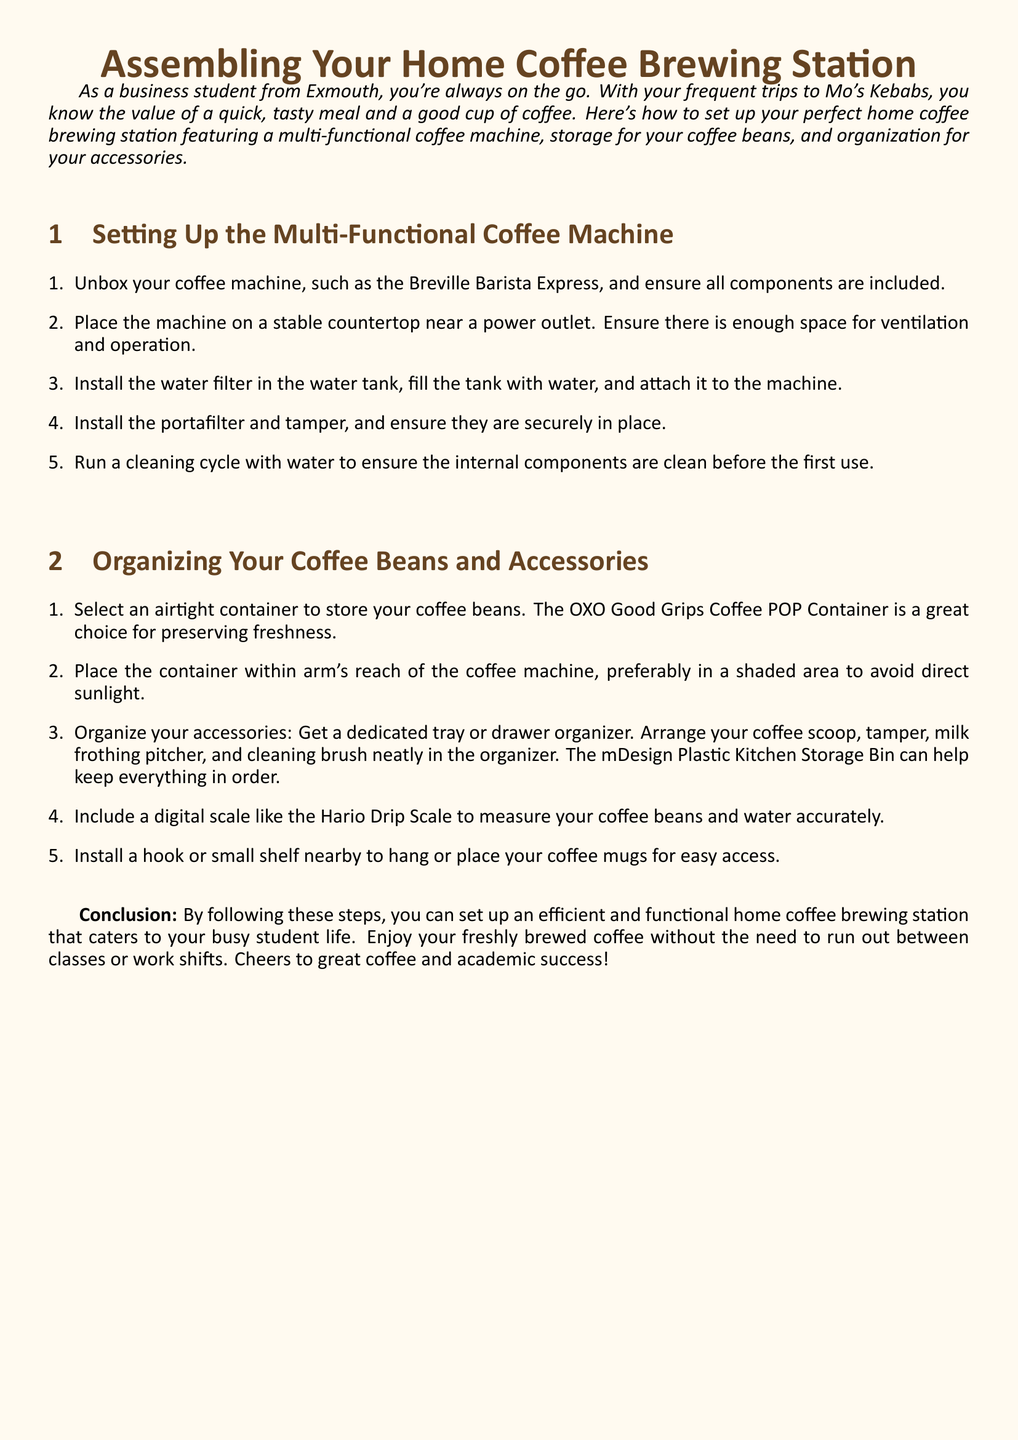What is the primary purpose of the document? The document provides assembly instructions for setting up a home coffee brewing station, including a coffee machine, storage for beans, and organization of accessories.
Answer: Assembling a home coffee brewing station What is the name of the coffee machine mentioned in the instructions? The document specifies the Breville Barista Express as the example coffee machine for assembly.
Answer: Breville Barista Express What type of container is recommended for storing coffee beans? The document suggests using an airtight container to preserve coffee bean freshness, specifically the OXO Good Grips Coffee POP Container.
Answer: OXO Good Grips Coffee POP Container How many steps are listed for setting up the multi-functional coffee machine? The document lists a total of five steps for assembling the coffee machine.
Answer: Five What accessory is mentioned as necessary for measuring coffee beans? The document recommends a digital scale, specifically the Hario Drip Scale, for accurate measurement of coffee beans and water.
Answer: Hario Drip Scale What is advised to be placed near the coffee machine for easy access? The document advises installing a hook or small shelf nearby to hang or place coffee mugs for convenience.
Answer: Coffee mugs What should be done before the first use of the coffee machine? The instructions state that a cleaning cycle with water should be run to ensure the internal components are clean.
Answer: Run a cleaning cycle What is the recommended location for storing the coffee bean container? The document suggests placing the coffee bean container in a shaded area to avoid direct sunlight.
Answer: Shaded area How can you organize your coffee accessories according to the document? The document recommends using a dedicated tray or drawer organizer to arrange coffee accessories neatly.
Answer: Drawer organizer 